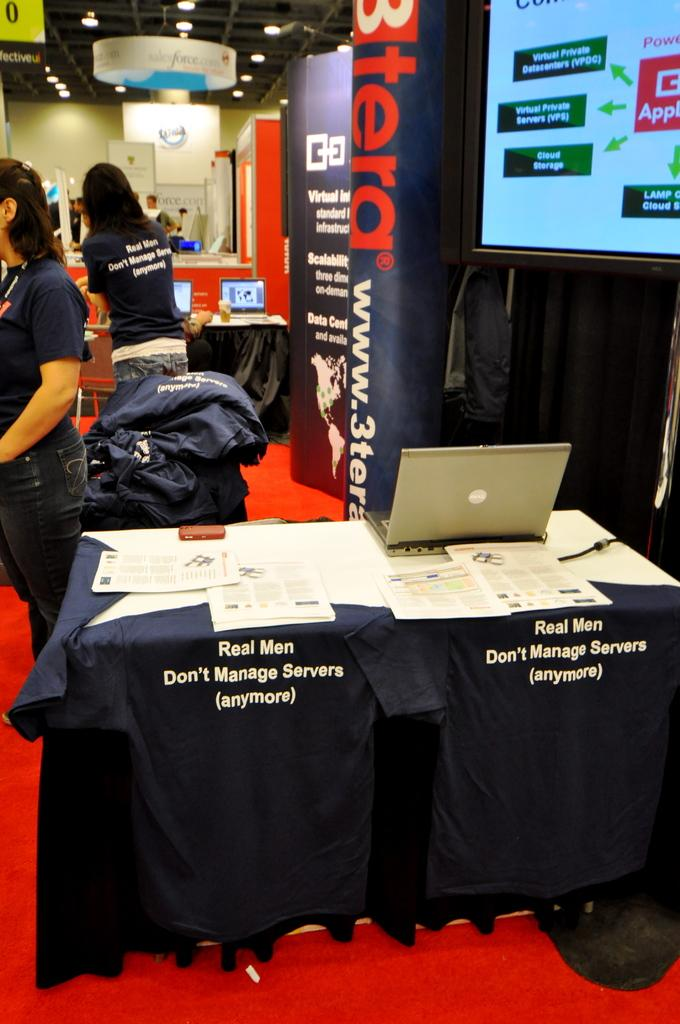What type of fabric is covering the tables in the image? There are tablecloths in the image. What electronic devices can be seen in the image? There are laptops in the image. What type of written material is present in the image? There are papers in the image. What is the large display in the image used for? There is a screen in the image, which is likely used for presentations or displays. What type of outdoor advertising is visible in the image? There are hoardings in the image. What type of signage is present in the image? There are boards in the image. Can you describe the people in the image? There are people in the image, but their specific actions or roles are not clear from the provided facts. What architectural features can be seen in the background of the image? There is a wall, a ceiling, and lights in the background of the image. What is the weight of the nut that is being cracked by the tail in the image? There is no nut or tail present in the image; the facts provided do not mention any such objects or actions. 